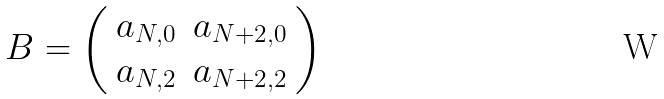<formula> <loc_0><loc_0><loc_500><loc_500>B = \left ( \begin{array} { c c } a _ { N , 0 } & a _ { N + 2 , 0 } \\ a _ { N , 2 } & a _ { N + 2 , 2 } \\ \end{array} \right )</formula> 